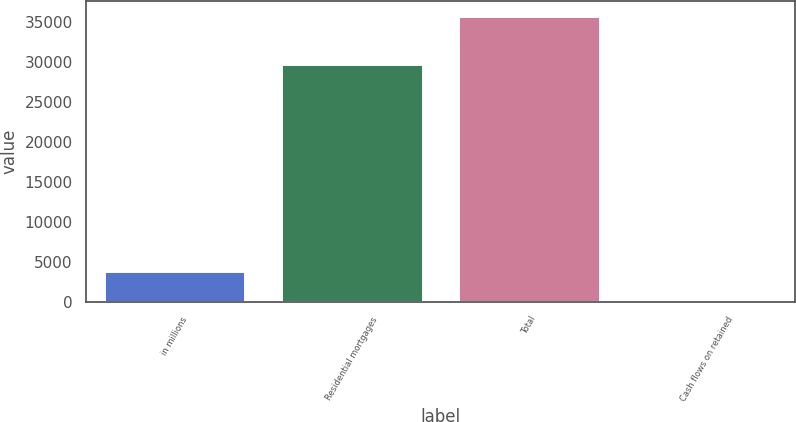Convert chart to OTSL. <chart><loc_0><loc_0><loc_500><loc_500><bar_chart><fcel>in millions<fcel>Residential mortgages<fcel>Total<fcel>Cash flows on retained<nl><fcel>3809.9<fcel>29772<fcel>35858<fcel>249<nl></chart> 